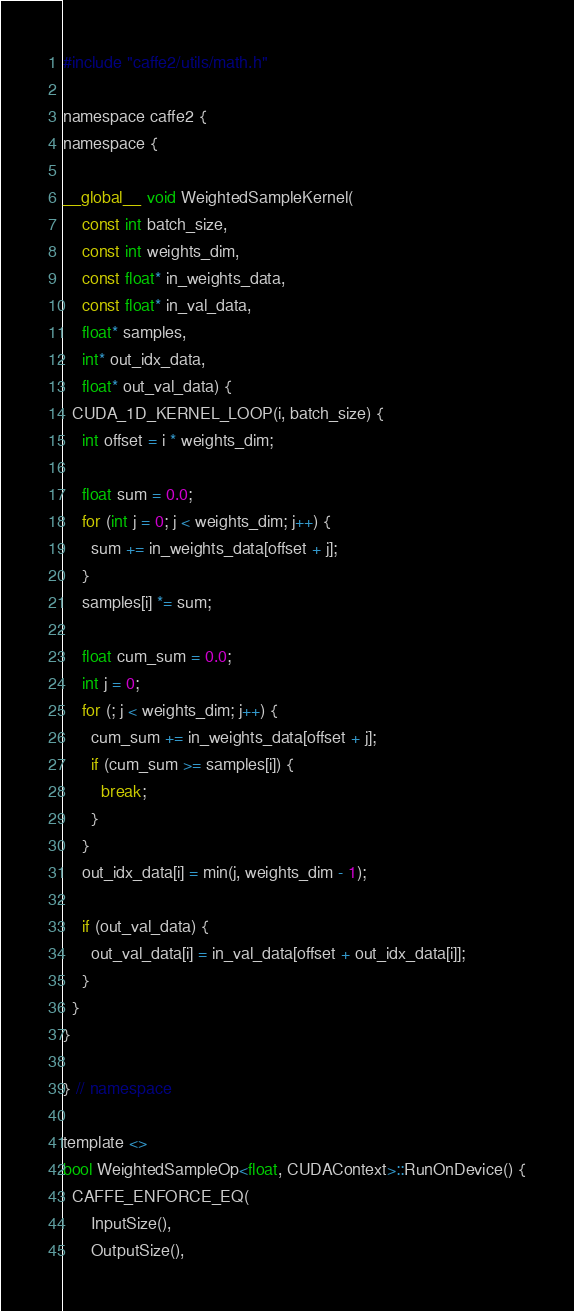Convert code to text. <code><loc_0><loc_0><loc_500><loc_500><_Cuda_>#include "caffe2/utils/math.h"

namespace caffe2 {
namespace {

__global__ void WeightedSampleKernel(
    const int batch_size,
    const int weights_dim,
    const float* in_weights_data,
    const float* in_val_data,
    float* samples,
    int* out_idx_data,
    float* out_val_data) {
  CUDA_1D_KERNEL_LOOP(i, batch_size) {
    int offset = i * weights_dim;

    float sum = 0.0;
    for (int j = 0; j < weights_dim; j++) {
      sum += in_weights_data[offset + j];
    }
    samples[i] *= sum;

    float cum_sum = 0.0;
    int j = 0;
    for (; j < weights_dim; j++) {
      cum_sum += in_weights_data[offset + j];
      if (cum_sum >= samples[i]) {
        break;
      }
    }
    out_idx_data[i] = min(j, weights_dim - 1);

    if (out_val_data) {
      out_val_data[i] = in_val_data[offset + out_idx_data[i]];
    }
  }
}

} // namespace

template <>
bool WeightedSampleOp<float, CUDAContext>::RunOnDevice() {
  CAFFE_ENFORCE_EQ(
      InputSize(),
      OutputSize(),</code> 